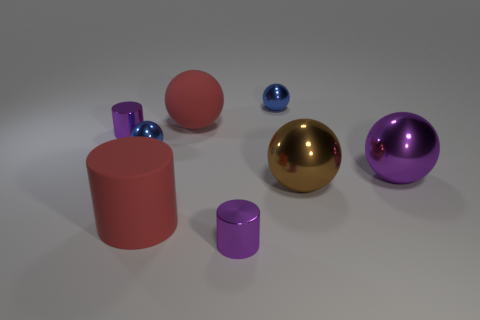How many things are either purple cylinders behind the large rubber cylinder or purple cylinders?
Provide a short and direct response. 2. Are there the same number of big red things and small yellow spheres?
Your response must be concise. No. There is a big thing that is made of the same material as the brown ball; what is its shape?
Provide a succinct answer. Sphere. What is the shape of the big brown metal thing?
Ensure brevity in your answer.  Sphere. There is a big object that is in front of the large purple shiny thing and right of the matte ball; what color is it?
Your answer should be compact. Brown. What shape is the purple object that is the same size as the red matte ball?
Offer a very short reply. Sphere. Is there a red rubber thing of the same shape as the big purple metal object?
Offer a very short reply. Yes. Is the large brown sphere made of the same material as the red object that is in front of the large brown ball?
Give a very brief answer. No. What is the color of the small cylinder that is on the left side of the purple object in front of the brown metallic sphere in front of the large purple ball?
Keep it short and to the point. Purple. There is a cylinder that is the same size as the red sphere; what is its material?
Keep it short and to the point. Rubber. 